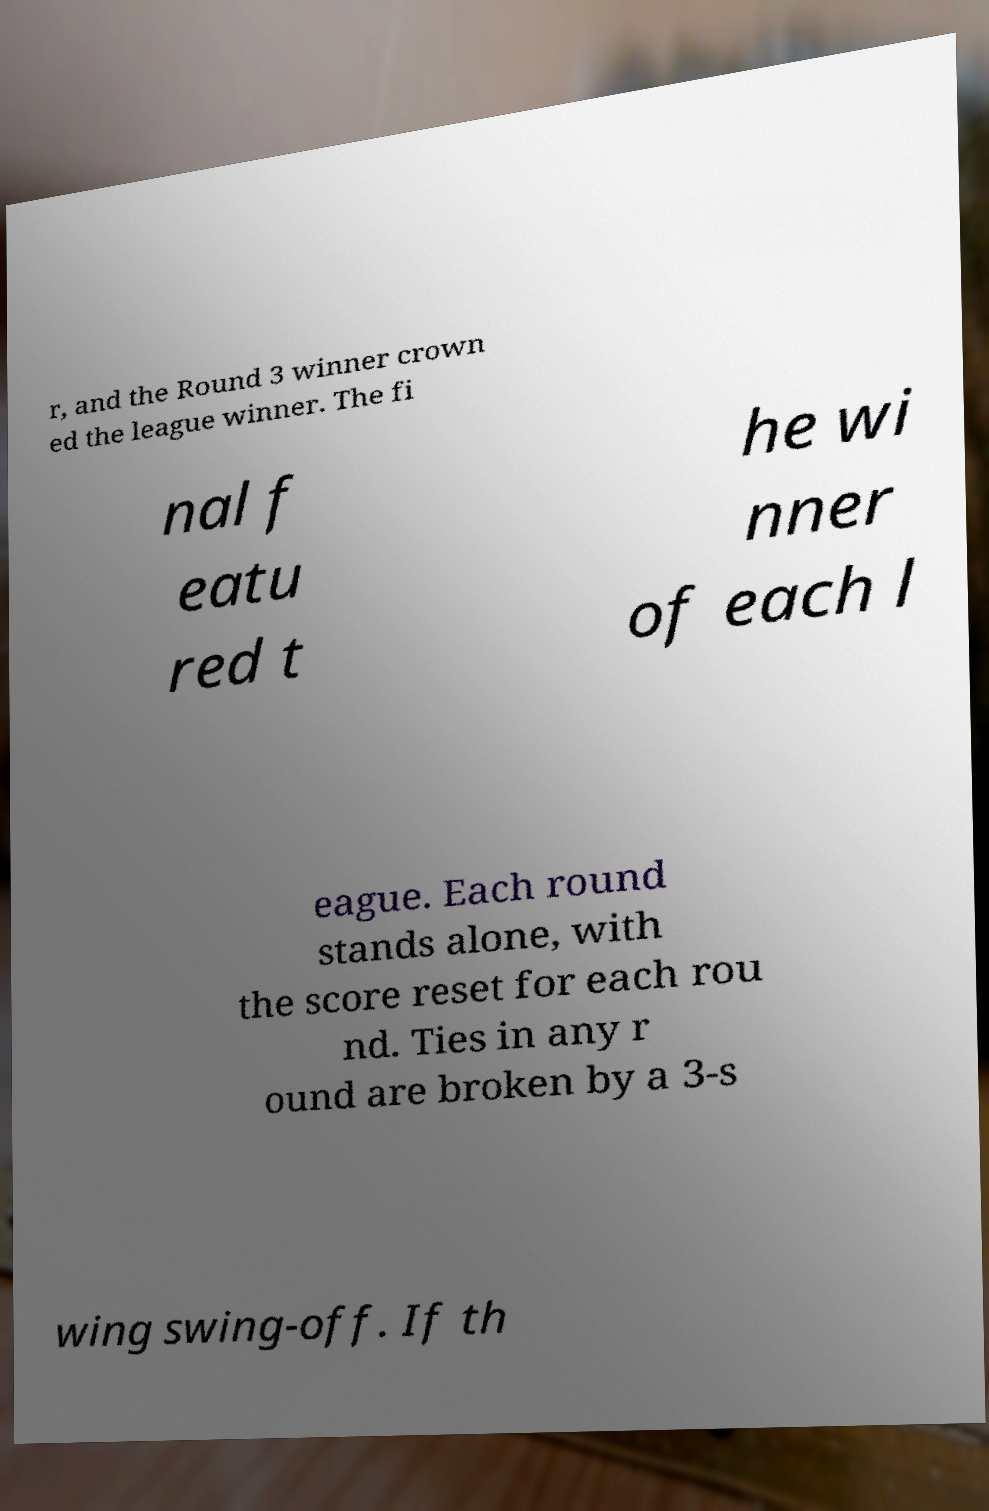I need the written content from this picture converted into text. Can you do that? r, and the Round 3 winner crown ed the league winner. The fi nal f eatu red t he wi nner of each l eague. Each round stands alone, with the score reset for each rou nd. Ties in any r ound are broken by a 3-s wing swing-off. If th 